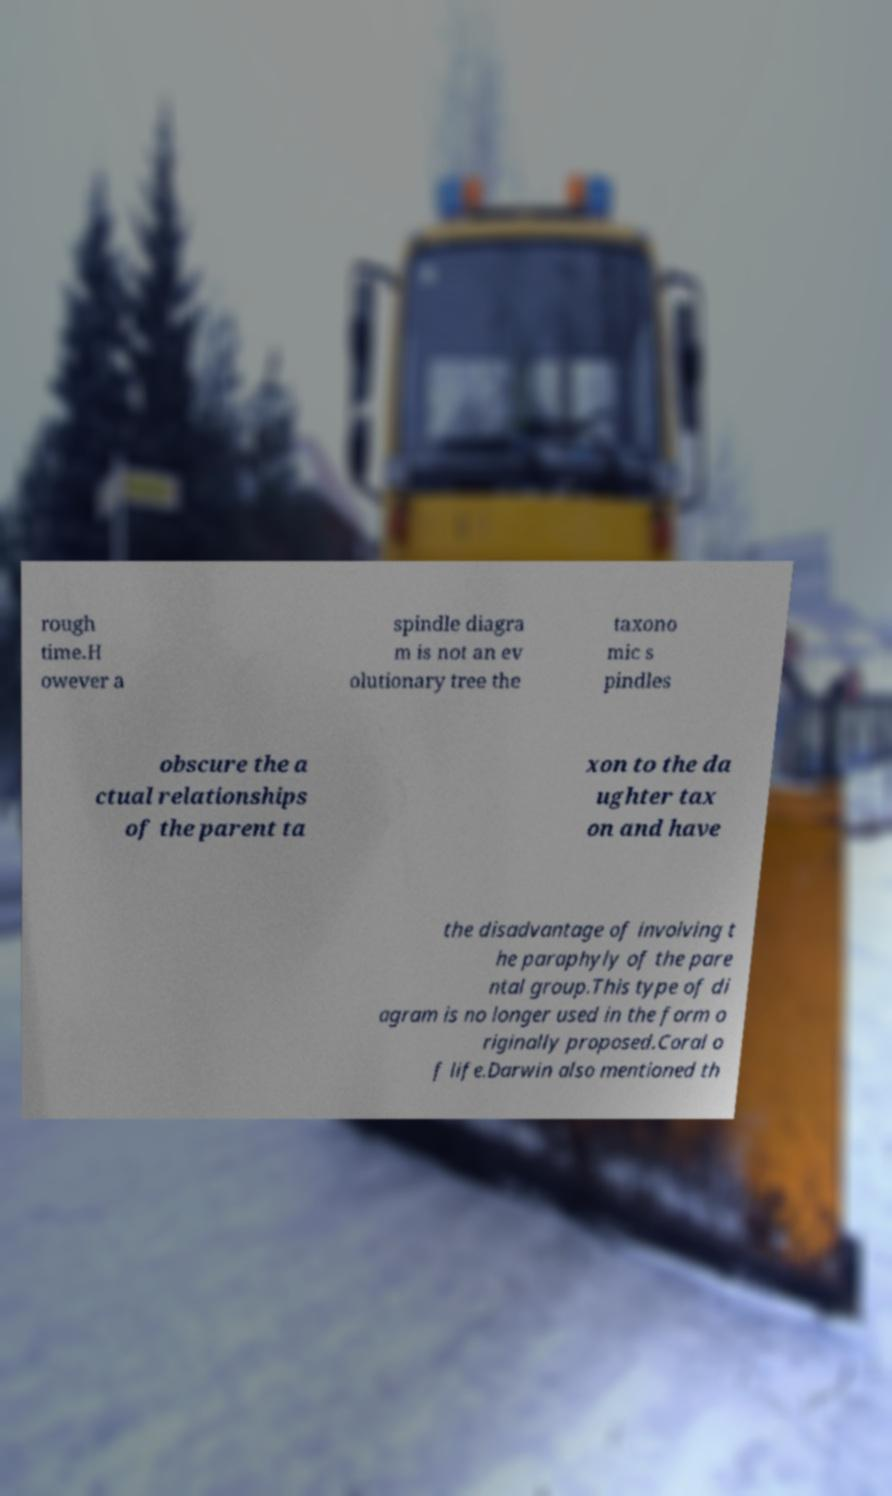For documentation purposes, I need the text within this image transcribed. Could you provide that? rough time.H owever a spindle diagra m is not an ev olutionary tree the taxono mic s pindles obscure the a ctual relationships of the parent ta xon to the da ughter tax on and have the disadvantage of involving t he paraphyly of the pare ntal group.This type of di agram is no longer used in the form o riginally proposed.Coral o f life.Darwin also mentioned th 